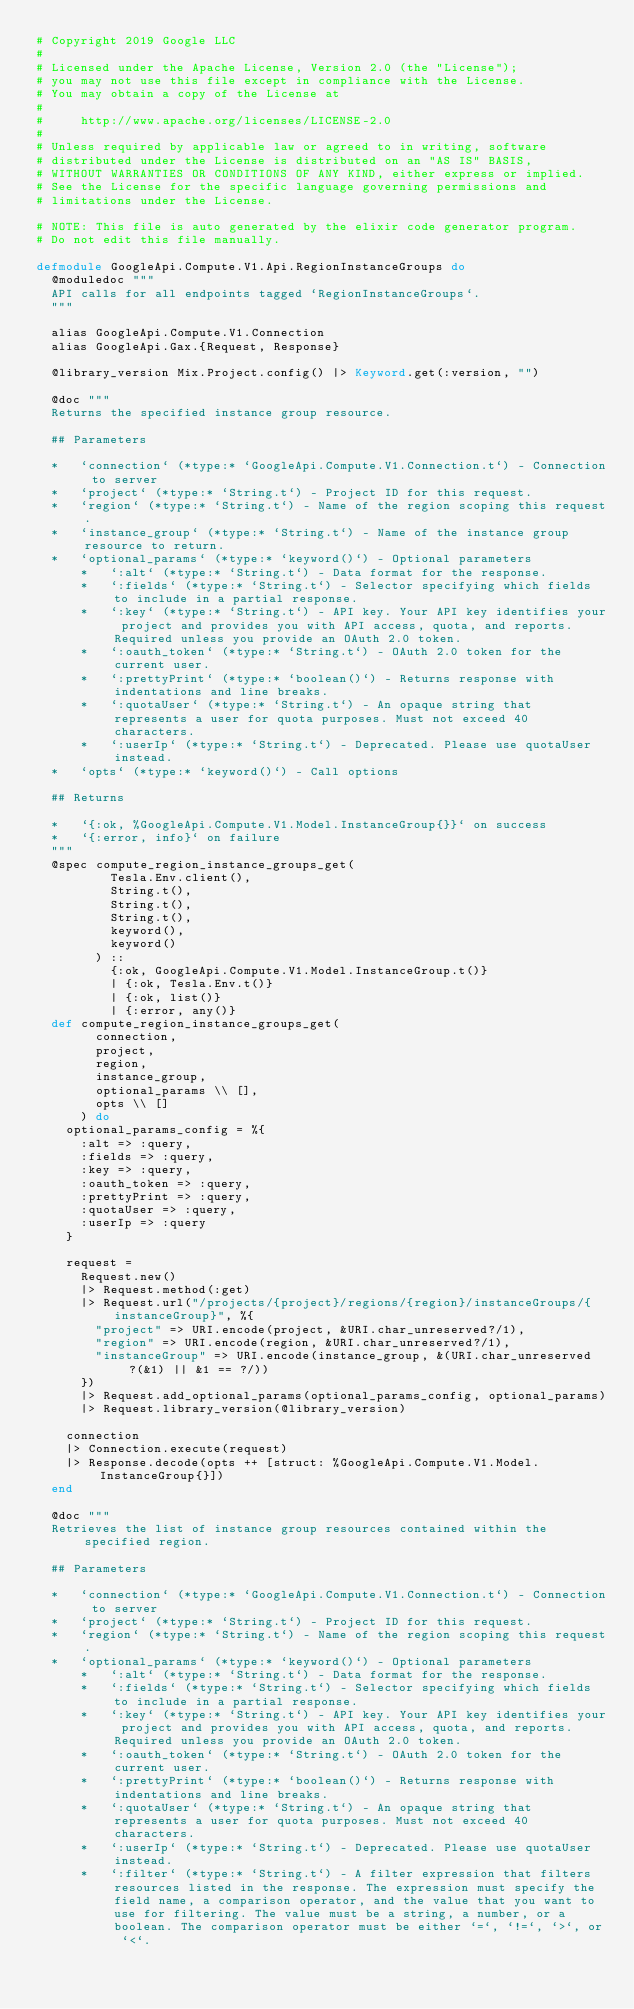<code> <loc_0><loc_0><loc_500><loc_500><_Elixir_># Copyright 2019 Google LLC
#
# Licensed under the Apache License, Version 2.0 (the "License");
# you may not use this file except in compliance with the License.
# You may obtain a copy of the License at
#
#     http://www.apache.org/licenses/LICENSE-2.0
#
# Unless required by applicable law or agreed to in writing, software
# distributed under the License is distributed on an "AS IS" BASIS,
# WITHOUT WARRANTIES OR CONDITIONS OF ANY KIND, either express or implied.
# See the License for the specific language governing permissions and
# limitations under the License.

# NOTE: This file is auto generated by the elixir code generator program.
# Do not edit this file manually.

defmodule GoogleApi.Compute.V1.Api.RegionInstanceGroups do
  @moduledoc """
  API calls for all endpoints tagged `RegionInstanceGroups`.
  """

  alias GoogleApi.Compute.V1.Connection
  alias GoogleApi.Gax.{Request, Response}

  @library_version Mix.Project.config() |> Keyword.get(:version, "")

  @doc """
  Returns the specified instance group resource.

  ## Parameters

  *   `connection` (*type:* `GoogleApi.Compute.V1.Connection.t`) - Connection to server
  *   `project` (*type:* `String.t`) - Project ID for this request.
  *   `region` (*type:* `String.t`) - Name of the region scoping this request.
  *   `instance_group` (*type:* `String.t`) - Name of the instance group resource to return.
  *   `optional_params` (*type:* `keyword()`) - Optional parameters
      *   `:alt` (*type:* `String.t`) - Data format for the response.
      *   `:fields` (*type:* `String.t`) - Selector specifying which fields to include in a partial response.
      *   `:key` (*type:* `String.t`) - API key. Your API key identifies your project and provides you with API access, quota, and reports. Required unless you provide an OAuth 2.0 token.
      *   `:oauth_token` (*type:* `String.t`) - OAuth 2.0 token for the current user.
      *   `:prettyPrint` (*type:* `boolean()`) - Returns response with indentations and line breaks.
      *   `:quotaUser` (*type:* `String.t`) - An opaque string that represents a user for quota purposes. Must not exceed 40 characters.
      *   `:userIp` (*type:* `String.t`) - Deprecated. Please use quotaUser instead.
  *   `opts` (*type:* `keyword()`) - Call options

  ## Returns

  *   `{:ok, %GoogleApi.Compute.V1.Model.InstanceGroup{}}` on success
  *   `{:error, info}` on failure
  """
  @spec compute_region_instance_groups_get(
          Tesla.Env.client(),
          String.t(),
          String.t(),
          String.t(),
          keyword(),
          keyword()
        ) ::
          {:ok, GoogleApi.Compute.V1.Model.InstanceGroup.t()}
          | {:ok, Tesla.Env.t()}
          | {:ok, list()}
          | {:error, any()}
  def compute_region_instance_groups_get(
        connection,
        project,
        region,
        instance_group,
        optional_params \\ [],
        opts \\ []
      ) do
    optional_params_config = %{
      :alt => :query,
      :fields => :query,
      :key => :query,
      :oauth_token => :query,
      :prettyPrint => :query,
      :quotaUser => :query,
      :userIp => :query
    }

    request =
      Request.new()
      |> Request.method(:get)
      |> Request.url("/projects/{project}/regions/{region}/instanceGroups/{instanceGroup}", %{
        "project" => URI.encode(project, &URI.char_unreserved?/1),
        "region" => URI.encode(region, &URI.char_unreserved?/1),
        "instanceGroup" => URI.encode(instance_group, &(URI.char_unreserved?(&1) || &1 == ?/))
      })
      |> Request.add_optional_params(optional_params_config, optional_params)
      |> Request.library_version(@library_version)

    connection
    |> Connection.execute(request)
    |> Response.decode(opts ++ [struct: %GoogleApi.Compute.V1.Model.InstanceGroup{}])
  end

  @doc """
  Retrieves the list of instance group resources contained within the specified region.

  ## Parameters

  *   `connection` (*type:* `GoogleApi.Compute.V1.Connection.t`) - Connection to server
  *   `project` (*type:* `String.t`) - Project ID for this request.
  *   `region` (*type:* `String.t`) - Name of the region scoping this request.
  *   `optional_params` (*type:* `keyword()`) - Optional parameters
      *   `:alt` (*type:* `String.t`) - Data format for the response.
      *   `:fields` (*type:* `String.t`) - Selector specifying which fields to include in a partial response.
      *   `:key` (*type:* `String.t`) - API key. Your API key identifies your project and provides you with API access, quota, and reports. Required unless you provide an OAuth 2.0 token.
      *   `:oauth_token` (*type:* `String.t`) - OAuth 2.0 token for the current user.
      *   `:prettyPrint` (*type:* `boolean()`) - Returns response with indentations and line breaks.
      *   `:quotaUser` (*type:* `String.t`) - An opaque string that represents a user for quota purposes. Must not exceed 40 characters.
      *   `:userIp` (*type:* `String.t`) - Deprecated. Please use quotaUser instead.
      *   `:filter` (*type:* `String.t`) - A filter expression that filters resources listed in the response. The expression must specify the field name, a comparison operator, and the value that you want to use for filtering. The value must be a string, a number, or a boolean. The comparison operator must be either `=`, `!=`, `>`, or `<`.
</code> 